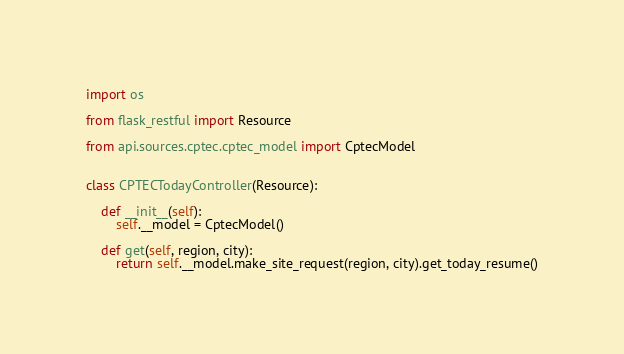Convert code to text. <code><loc_0><loc_0><loc_500><loc_500><_Python_>import os

from flask_restful import Resource

from api.sources.cptec.cptec_model import CptecModel


class CPTECTodayController(Resource):

    def __init__(self):
        self.__model = CptecModel()

    def get(self, region, city):
        return self.__model.make_site_request(region, city).get_today_resume()
</code> 